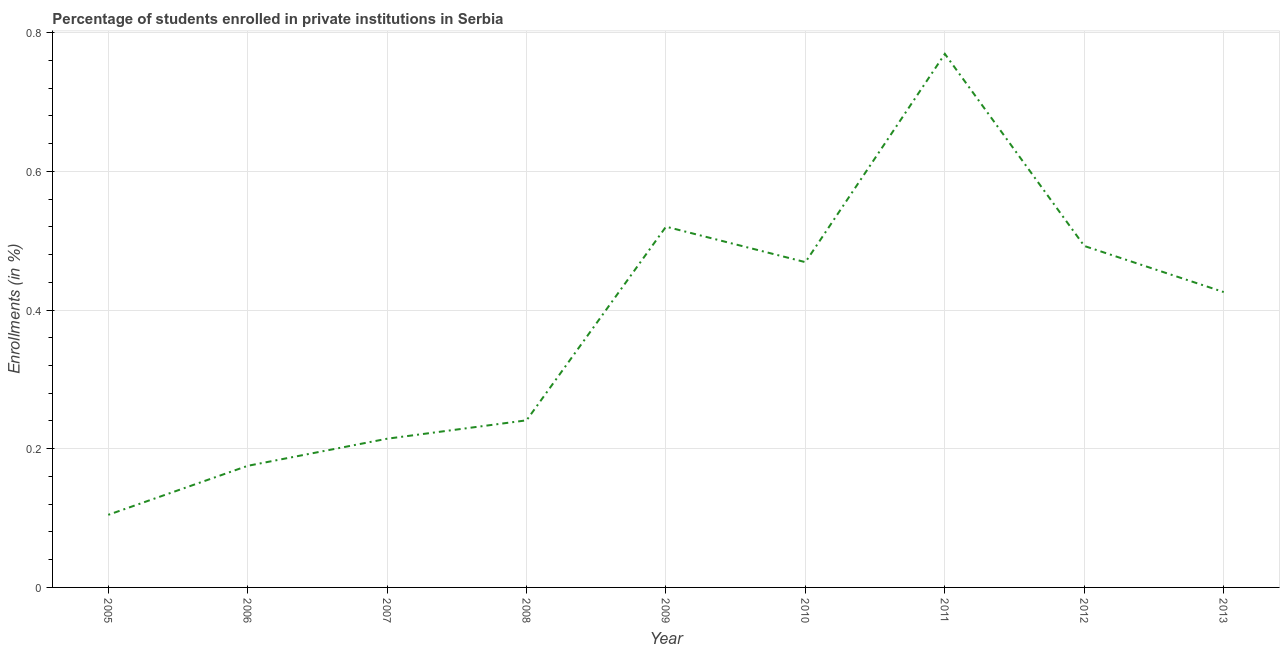What is the enrollments in private institutions in 2012?
Offer a terse response. 0.49. Across all years, what is the maximum enrollments in private institutions?
Keep it short and to the point. 0.77. Across all years, what is the minimum enrollments in private institutions?
Offer a very short reply. 0.1. In which year was the enrollments in private institutions minimum?
Make the answer very short. 2005. What is the sum of the enrollments in private institutions?
Offer a terse response. 3.41. What is the difference between the enrollments in private institutions in 2010 and 2013?
Your answer should be compact. 0.04. What is the average enrollments in private institutions per year?
Make the answer very short. 0.38. What is the median enrollments in private institutions?
Keep it short and to the point. 0.43. Do a majority of the years between 2009 and 2011 (inclusive) have enrollments in private institutions greater than 0.16 %?
Provide a succinct answer. Yes. What is the ratio of the enrollments in private institutions in 2010 to that in 2012?
Keep it short and to the point. 0.95. What is the difference between the highest and the second highest enrollments in private institutions?
Provide a succinct answer. 0.25. What is the difference between the highest and the lowest enrollments in private institutions?
Provide a short and direct response. 0.66. Does the enrollments in private institutions monotonically increase over the years?
Provide a short and direct response. No. How many lines are there?
Offer a very short reply. 1. How many years are there in the graph?
Offer a very short reply. 9. Does the graph contain grids?
Provide a short and direct response. Yes. What is the title of the graph?
Give a very brief answer. Percentage of students enrolled in private institutions in Serbia. What is the label or title of the Y-axis?
Your answer should be very brief. Enrollments (in %). What is the Enrollments (in %) of 2005?
Offer a very short reply. 0.1. What is the Enrollments (in %) in 2006?
Your answer should be compact. 0.18. What is the Enrollments (in %) in 2007?
Provide a succinct answer. 0.21. What is the Enrollments (in %) of 2008?
Make the answer very short. 0.24. What is the Enrollments (in %) of 2009?
Keep it short and to the point. 0.52. What is the Enrollments (in %) in 2010?
Provide a succinct answer. 0.47. What is the Enrollments (in %) of 2011?
Offer a very short reply. 0.77. What is the Enrollments (in %) of 2012?
Give a very brief answer. 0.49. What is the Enrollments (in %) of 2013?
Your answer should be very brief. 0.43. What is the difference between the Enrollments (in %) in 2005 and 2006?
Give a very brief answer. -0.07. What is the difference between the Enrollments (in %) in 2005 and 2007?
Keep it short and to the point. -0.11. What is the difference between the Enrollments (in %) in 2005 and 2008?
Ensure brevity in your answer.  -0.14. What is the difference between the Enrollments (in %) in 2005 and 2009?
Provide a succinct answer. -0.42. What is the difference between the Enrollments (in %) in 2005 and 2010?
Provide a succinct answer. -0.36. What is the difference between the Enrollments (in %) in 2005 and 2011?
Give a very brief answer. -0.66. What is the difference between the Enrollments (in %) in 2005 and 2012?
Provide a succinct answer. -0.39. What is the difference between the Enrollments (in %) in 2005 and 2013?
Your answer should be very brief. -0.32. What is the difference between the Enrollments (in %) in 2006 and 2007?
Make the answer very short. -0.04. What is the difference between the Enrollments (in %) in 2006 and 2008?
Your answer should be compact. -0.07. What is the difference between the Enrollments (in %) in 2006 and 2009?
Offer a terse response. -0.34. What is the difference between the Enrollments (in %) in 2006 and 2010?
Offer a terse response. -0.29. What is the difference between the Enrollments (in %) in 2006 and 2011?
Provide a short and direct response. -0.59. What is the difference between the Enrollments (in %) in 2006 and 2012?
Give a very brief answer. -0.32. What is the difference between the Enrollments (in %) in 2006 and 2013?
Keep it short and to the point. -0.25. What is the difference between the Enrollments (in %) in 2007 and 2008?
Your answer should be compact. -0.03. What is the difference between the Enrollments (in %) in 2007 and 2009?
Your response must be concise. -0.31. What is the difference between the Enrollments (in %) in 2007 and 2010?
Make the answer very short. -0.25. What is the difference between the Enrollments (in %) in 2007 and 2011?
Provide a succinct answer. -0.55. What is the difference between the Enrollments (in %) in 2007 and 2012?
Your response must be concise. -0.28. What is the difference between the Enrollments (in %) in 2007 and 2013?
Provide a succinct answer. -0.21. What is the difference between the Enrollments (in %) in 2008 and 2009?
Your answer should be compact. -0.28. What is the difference between the Enrollments (in %) in 2008 and 2010?
Your answer should be very brief. -0.23. What is the difference between the Enrollments (in %) in 2008 and 2011?
Make the answer very short. -0.53. What is the difference between the Enrollments (in %) in 2008 and 2012?
Give a very brief answer. -0.25. What is the difference between the Enrollments (in %) in 2008 and 2013?
Make the answer very short. -0.18. What is the difference between the Enrollments (in %) in 2009 and 2010?
Offer a terse response. 0.05. What is the difference between the Enrollments (in %) in 2009 and 2011?
Ensure brevity in your answer.  -0.25. What is the difference between the Enrollments (in %) in 2009 and 2012?
Your answer should be compact. 0.03. What is the difference between the Enrollments (in %) in 2009 and 2013?
Offer a terse response. 0.09. What is the difference between the Enrollments (in %) in 2010 and 2011?
Provide a succinct answer. -0.3. What is the difference between the Enrollments (in %) in 2010 and 2012?
Provide a short and direct response. -0.02. What is the difference between the Enrollments (in %) in 2010 and 2013?
Provide a succinct answer. 0.04. What is the difference between the Enrollments (in %) in 2011 and 2012?
Your response must be concise. 0.28. What is the difference between the Enrollments (in %) in 2011 and 2013?
Offer a terse response. 0.34. What is the difference between the Enrollments (in %) in 2012 and 2013?
Make the answer very short. 0.07. What is the ratio of the Enrollments (in %) in 2005 to that in 2006?
Ensure brevity in your answer.  0.6. What is the ratio of the Enrollments (in %) in 2005 to that in 2007?
Offer a terse response. 0.49. What is the ratio of the Enrollments (in %) in 2005 to that in 2008?
Offer a very short reply. 0.43. What is the ratio of the Enrollments (in %) in 2005 to that in 2009?
Offer a terse response. 0.2. What is the ratio of the Enrollments (in %) in 2005 to that in 2010?
Ensure brevity in your answer.  0.22. What is the ratio of the Enrollments (in %) in 2005 to that in 2011?
Make the answer very short. 0.14. What is the ratio of the Enrollments (in %) in 2005 to that in 2012?
Provide a short and direct response. 0.21. What is the ratio of the Enrollments (in %) in 2005 to that in 2013?
Ensure brevity in your answer.  0.25. What is the ratio of the Enrollments (in %) in 2006 to that in 2007?
Offer a very short reply. 0.82. What is the ratio of the Enrollments (in %) in 2006 to that in 2008?
Your response must be concise. 0.73. What is the ratio of the Enrollments (in %) in 2006 to that in 2009?
Give a very brief answer. 0.34. What is the ratio of the Enrollments (in %) in 2006 to that in 2010?
Your answer should be very brief. 0.37. What is the ratio of the Enrollments (in %) in 2006 to that in 2011?
Give a very brief answer. 0.23. What is the ratio of the Enrollments (in %) in 2006 to that in 2012?
Keep it short and to the point. 0.36. What is the ratio of the Enrollments (in %) in 2006 to that in 2013?
Your answer should be compact. 0.41. What is the ratio of the Enrollments (in %) in 2007 to that in 2008?
Give a very brief answer. 0.89. What is the ratio of the Enrollments (in %) in 2007 to that in 2009?
Make the answer very short. 0.41. What is the ratio of the Enrollments (in %) in 2007 to that in 2010?
Your response must be concise. 0.46. What is the ratio of the Enrollments (in %) in 2007 to that in 2011?
Provide a succinct answer. 0.28. What is the ratio of the Enrollments (in %) in 2007 to that in 2012?
Ensure brevity in your answer.  0.44. What is the ratio of the Enrollments (in %) in 2007 to that in 2013?
Make the answer very short. 0.5. What is the ratio of the Enrollments (in %) in 2008 to that in 2009?
Offer a terse response. 0.46. What is the ratio of the Enrollments (in %) in 2008 to that in 2010?
Your answer should be very brief. 0.51. What is the ratio of the Enrollments (in %) in 2008 to that in 2011?
Make the answer very short. 0.31. What is the ratio of the Enrollments (in %) in 2008 to that in 2012?
Make the answer very short. 0.49. What is the ratio of the Enrollments (in %) in 2008 to that in 2013?
Keep it short and to the point. 0.57. What is the ratio of the Enrollments (in %) in 2009 to that in 2010?
Provide a succinct answer. 1.11. What is the ratio of the Enrollments (in %) in 2009 to that in 2011?
Your response must be concise. 0.68. What is the ratio of the Enrollments (in %) in 2009 to that in 2012?
Keep it short and to the point. 1.06. What is the ratio of the Enrollments (in %) in 2009 to that in 2013?
Provide a short and direct response. 1.22. What is the ratio of the Enrollments (in %) in 2010 to that in 2011?
Keep it short and to the point. 0.61. What is the ratio of the Enrollments (in %) in 2010 to that in 2012?
Offer a terse response. 0.95. What is the ratio of the Enrollments (in %) in 2010 to that in 2013?
Ensure brevity in your answer.  1.1. What is the ratio of the Enrollments (in %) in 2011 to that in 2012?
Keep it short and to the point. 1.56. What is the ratio of the Enrollments (in %) in 2011 to that in 2013?
Offer a very short reply. 1.81. What is the ratio of the Enrollments (in %) in 2012 to that in 2013?
Ensure brevity in your answer.  1.16. 